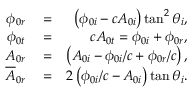Convert formula to latex. <formula><loc_0><loc_0><loc_500><loc_500>\begin{array} { r l r } { \phi _ { 0 r } } & = } & { \left ( \phi _ { 0 i } - c A _ { 0 i } \right ) \tan ^ { 2 } \theta _ { i } , } \\ { \phi _ { 0 t } } & = } & { c A _ { 0 t } = \phi _ { 0 i } + \phi _ { 0 r } , } \\ { A _ { 0 r } } & = } & { \left ( A _ { 0 i } - \phi _ { 0 i } / c + \phi _ { 0 r } / c \right ) , } \\ { \overline { A } _ { 0 r } } & = } & { 2 \left ( \phi _ { 0 i } / c - A _ { 0 i } \right ) \tan \theta _ { i } . } \end{array}</formula> 